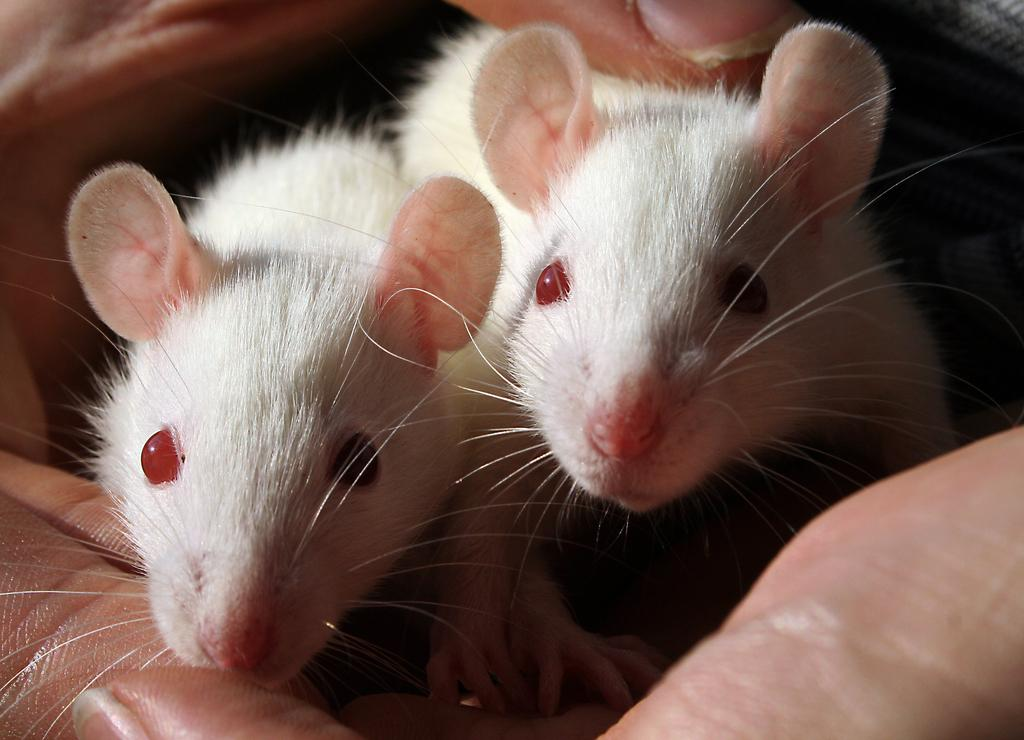What type of animals are in the image? There are two white color mouses in the image. Who is holding the mouses? The mouses are in the hands of a person. What type of sign can be seen in the image? There is no sign present in the image; it only features two white color mouses and a person holding them. How many planes are visible in the image? There are no planes visible in the image. 